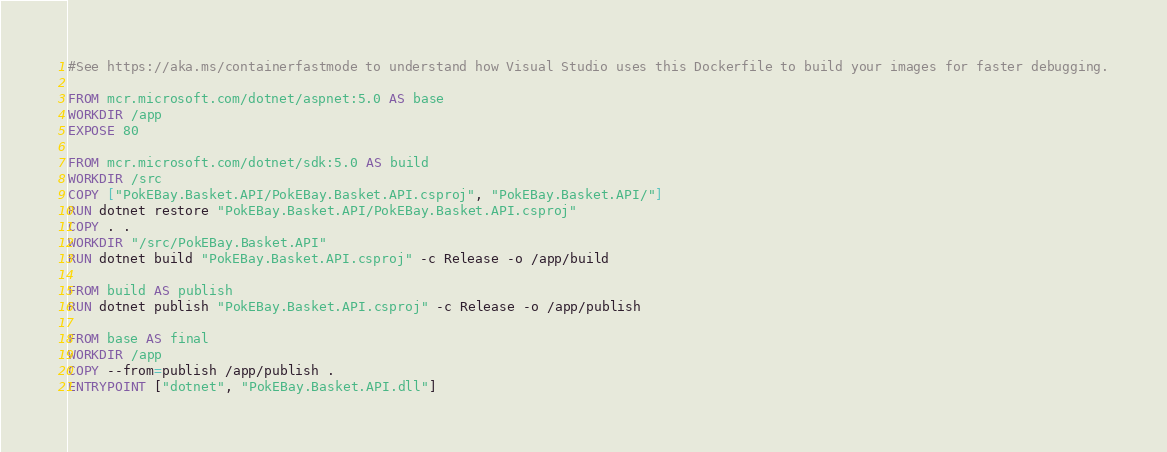Convert code to text. <code><loc_0><loc_0><loc_500><loc_500><_Dockerfile_>#See https://aka.ms/containerfastmode to understand how Visual Studio uses this Dockerfile to build your images for faster debugging.

FROM mcr.microsoft.com/dotnet/aspnet:5.0 AS base
WORKDIR /app
EXPOSE 80

FROM mcr.microsoft.com/dotnet/sdk:5.0 AS build
WORKDIR /src
COPY ["PokEBay.Basket.API/PokEBay.Basket.API.csproj", "PokEBay.Basket.API/"]
RUN dotnet restore "PokEBay.Basket.API/PokEBay.Basket.API.csproj"
COPY . .
WORKDIR "/src/PokEBay.Basket.API"
RUN dotnet build "PokEBay.Basket.API.csproj" -c Release -o /app/build

FROM build AS publish
RUN dotnet publish "PokEBay.Basket.API.csproj" -c Release -o /app/publish

FROM base AS final
WORKDIR /app
COPY --from=publish /app/publish .
ENTRYPOINT ["dotnet", "PokEBay.Basket.API.dll"]
</code> 